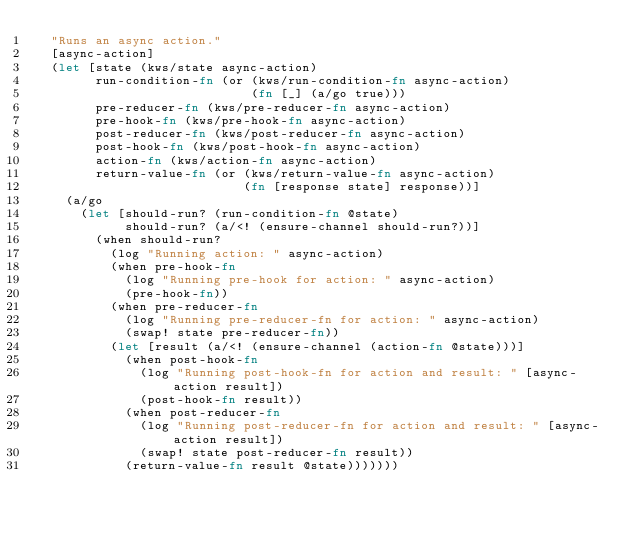<code> <loc_0><loc_0><loc_500><loc_500><_Clojure_>  "Runs an async action."
  [async-action]
  (let [state (kws/state async-action)
        run-condition-fn (or (kws/run-condition-fn async-action)
                             (fn [_] (a/go true)))
        pre-reducer-fn (kws/pre-reducer-fn async-action)
        pre-hook-fn (kws/pre-hook-fn async-action)
        post-reducer-fn (kws/post-reducer-fn async-action)
        post-hook-fn (kws/post-hook-fn async-action)
        action-fn (kws/action-fn async-action)
        return-value-fn (or (kws/return-value-fn async-action)
                            (fn [response state] response))]
    (a/go
      (let [should-run? (run-condition-fn @state)
            should-run? (a/<! (ensure-channel should-run?))]
        (when should-run?
          (log "Running action: " async-action)
          (when pre-hook-fn
            (log "Running pre-hook for action: " async-action)
            (pre-hook-fn))
          (when pre-reducer-fn
            (log "Running pre-reducer-fn for action: " async-action)
            (swap! state pre-reducer-fn))
          (let [result (a/<! (ensure-channel (action-fn @state)))]
            (when post-hook-fn
              (log "Running post-hook-fn for action and result: " [async-action result])
              (post-hook-fn result))
            (when post-reducer-fn
              (log "Running post-reducer-fn for action and result: " [async-action result])
              (swap! state post-reducer-fn result))
            (return-value-fn result @state)))))))
</code> 